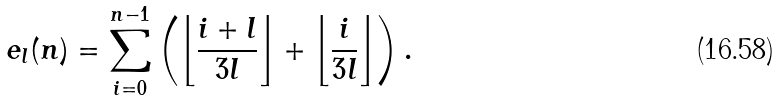Convert formula to latex. <formula><loc_0><loc_0><loc_500><loc_500>e _ { l } ( n ) = \sum _ { i = 0 } ^ { n - 1 } \left ( \left \lfloor \frac { i + l } { 3 l } \right \rfloor + \left \lfloor \frac { i } { 3 l } \right \rfloor \right ) .</formula> 